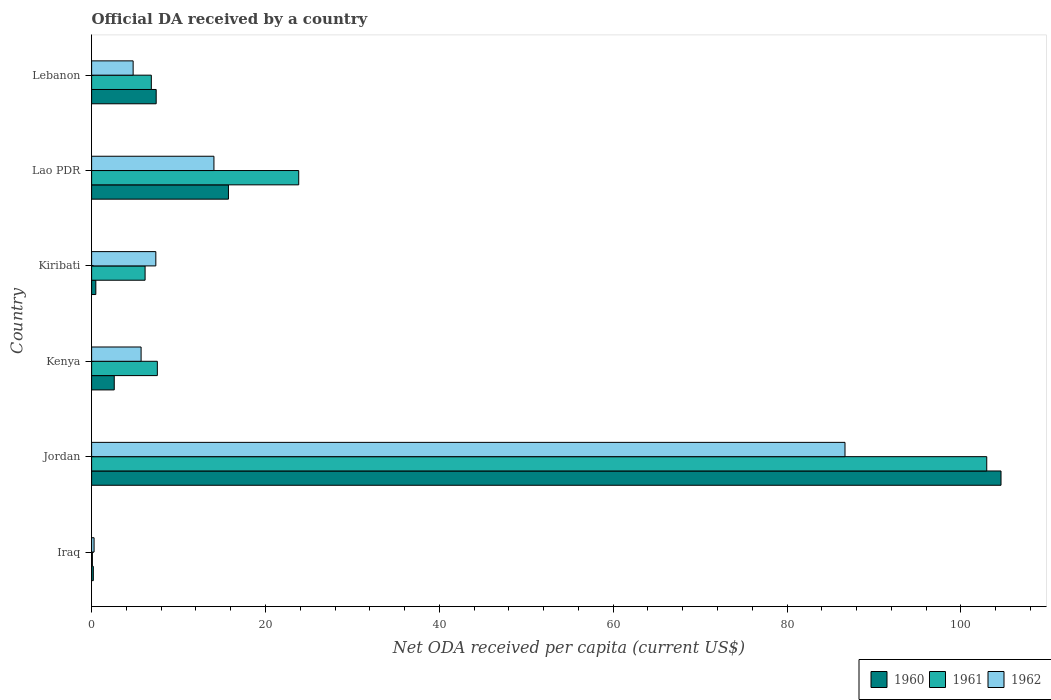How many different coloured bars are there?
Ensure brevity in your answer.  3. How many groups of bars are there?
Ensure brevity in your answer.  6. Are the number of bars per tick equal to the number of legend labels?
Make the answer very short. Yes. Are the number of bars on each tick of the Y-axis equal?
Give a very brief answer. Yes. What is the label of the 1st group of bars from the top?
Provide a succinct answer. Lebanon. In how many cases, is the number of bars for a given country not equal to the number of legend labels?
Keep it short and to the point. 0. What is the ODA received in in 1961 in Kenya?
Provide a succinct answer. 7.56. Across all countries, what is the maximum ODA received in in 1961?
Ensure brevity in your answer.  102.97. Across all countries, what is the minimum ODA received in in 1962?
Your answer should be compact. 0.28. In which country was the ODA received in in 1962 maximum?
Offer a terse response. Jordan. In which country was the ODA received in in 1962 minimum?
Give a very brief answer. Iraq. What is the total ODA received in in 1962 in the graph?
Your answer should be very brief. 118.88. What is the difference between the ODA received in in 1960 in Kenya and that in Kiribati?
Make the answer very short. 2.12. What is the difference between the ODA received in in 1961 in Kiribati and the ODA received in in 1962 in Lebanon?
Provide a short and direct response. 1.37. What is the average ODA received in in 1961 per country?
Give a very brief answer. 24.58. What is the difference between the ODA received in in 1960 and ODA received in in 1961 in Lebanon?
Your response must be concise. 0.56. In how many countries, is the ODA received in in 1962 greater than 104 US$?
Offer a terse response. 0. What is the ratio of the ODA received in in 1960 in Jordan to that in Lebanon?
Offer a very short reply. 14.08. Is the difference between the ODA received in in 1960 in Kenya and Lao PDR greater than the difference between the ODA received in in 1961 in Kenya and Lao PDR?
Your answer should be very brief. Yes. What is the difference between the highest and the second highest ODA received in in 1962?
Give a very brief answer. 72.59. What is the difference between the highest and the lowest ODA received in in 1962?
Your answer should be compact. 86.38. In how many countries, is the ODA received in in 1960 greater than the average ODA received in in 1960 taken over all countries?
Your response must be concise. 1. What does the 1st bar from the bottom in Kenya represents?
Offer a very short reply. 1960. Is it the case that in every country, the sum of the ODA received in in 1960 and ODA received in in 1962 is greater than the ODA received in in 1961?
Provide a succinct answer. Yes. How many countries are there in the graph?
Keep it short and to the point. 6. What is the difference between two consecutive major ticks on the X-axis?
Your response must be concise. 20. Where does the legend appear in the graph?
Provide a succinct answer. Bottom right. What is the title of the graph?
Your answer should be very brief. Official DA received by a country. What is the label or title of the X-axis?
Provide a succinct answer. Net ODA received per capita (current US$). What is the label or title of the Y-axis?
Keep it short and to the point. Country. What is the Net ODA received per capita (current US$) of 1960 in Iraq?
Give a very brief answer. 0.2. What is the Net ODA received per capita (current US$) of 1961 in Iraq?
Provide a short and direct response. 0.09. What is the Net ODA received per capita (current US$) in 1962 in Iraq?
Make the answer very short. 0.28. What is the Net ODA received per capita (current US$) in 1960 in Jordan?
Your response must be concise. 104.61. What is the Net ODA received per capita (current US$) in 1961 in Jordan?
Offer a very short reply. 102.97. What is the Net ODA received per capita (current US$) in 1962 in Jordan?
Offer a terse response. 86.66. What is the Net ODA received per capita (current US$) of 1960 in Kenya?
Make the answer very short. 2.6. What is the Net ODA received per capita (current US$) of 1961 in Kenya?
Make the answer very short. 7.56. What is the Net ODA received per capita (current US$) in 1962 in Kenya?
Give a very brief answer. 5.69. What is the Net ODA received per capita (current US$) of 1960 in Kiribati?
Make the answer very short. 0.49. What is the Net ODA received per capita (current US$) in 1961 in Kiribati?
Your response must be concise. 6.15. What is the Net ODA received per capita (current US$) of 1962 in Kiribati?
Your answer should be compact. 7.39. What is the Net ODA received per capita (current US$) of 1960 in Lao PDR?
Your answer should be compact. 15.74. What is the Net ODA received per capita (current US$) in 1961 in Lao PDR?
Make the answer very short. 23.82. What is the Net ODA received per capita (current US$) in 1962 in Lao PDR?
Your response must be concise. 14.07. What is the Net ODA received per capita (current US$) in 1960 in Lebanon?
Offer a terse response. 7.43. What is the Net ODA received per capita (current US$) of 1961 in Lebanon?
Keep it short and to the point. 6.87. What is the Net ODA received per capita (current US$) in 1962 in Lebanon?
Make the answer very short. 4.78. Across all countries, what is the maximum Net ODA received per capita (current US$) of 1960?
Make the answer very short. 104.61. Across all countries, what is the maximum Net ODA received per capita (current US$) of 1961?
Your answer should be compact. 102.97. Across all countries, what is the maximum Net ODA received per capita (current US$) in 1962?
Provide a succinct answer. 86.66. Across all countries, what is the minimum Net ODA received per capita (current US$) in 1960?
Provide a short and direct response. 0.2. Across all countries, what is the minimum Net ODA received per capita (current US$) in 1961?
Your answer should be compact. 0.09. Across all countries, what is the minimum Net ODA received per capita (current US$) of 1962?
Your response must be concise. 0.28. What is the total Net ODA received per capita (current US$) of 1960 in the graph?
Offer a terse response. 131.07. What is the total Net ODA received per capita (current US$) of 1961 in the graph?
Keep it short and to the point. 147.47. What is the total Net ODA received per capita (current US$) in 1962 in the graph?
Offer a very short reply. 118.88. What is the difference between the Net ODA received per capita (current US$) in 1960 in Iraq and that in Jordan?
Give a very brief answer. -104.41. What is the difference between the Net ODA received per capita (current US$) of 1961 in Iraq and that in Jordan?
Make the answer very short. -102.88. What is the difference between the Net ODA received per capita (current US$) of 1962 in Iraq and that in Jordan?
Your answer should be compact. -86.38. What is the difference between the Net ODA received per capita (current US$) of 1960 in Iraq and that in Kenya?
Provide a short and direct response. -2.41. What is the difference between the Net ODA received per capita (current US$) in 1961 in Iraq and that in Kenya?
Your answer should be very brief. -7.47. What is the difference between the Net ODA received per capita (current US$) in 1962 in Iraq and that in Kenya?
Your answer should be very brief. -5.41. What is the difference between the Net ODA received per capita (current US$) of 1960 in Iraq and that in Kiribati?
Your answer should be very brief. -0.29. What is the difference between the Net ODA received per capita (current US$) of 1961 in Iraq and that in Kiribati?
Provide a short and direct response. -6.06. What is the difference between the Net ODA received per capita (current US$) of 1962 in Iraq and that in Kiribati?
Keep it short and to the point. -7.1. What is the difference between the Net ODA received per capita (current US$) of 1960 in Iraq and that in Lao PDR?
Provide a succinct answer. -15.54. What is the difference between the Net ODA received per capita (current US$) in 1961 in Iraq and that in Lao PDR?
Keep it short and to the point. -23.73. What is the difference between the Net ODA received per capita (current US$) in 1962 in Iraq and that in Lao PDR?
Your response must be concise. -13.79. What is the difference between the Net ODA received per capita (current US$) of 1960 in Iraq and that in Lebanon?
Provide a succinct answer. -7.23. What is the difference between the Net ODA received per capita (current US$) in 1961 in Iraq and that in Lebanon?
Your answer should be very brief. -6.78. What is the difference between the Net ODA received per capita (current US$) in 1962 in Iraq and that in Lebanon?
Keep it short and to the point. -4.49. What is the difference between the Net ODA received per capita (current US$) in 1960 in Jordan and that in Kenya?
Your answer should be very brief. 102. What is the difference between the Net ODA received per capita (current US$) of 1961 in Jordan and that in Kenya?
Your response must be concise. 95.4. What is the difference between the Net ODA received per capita (current US$) in 1962 in Jordan and that in Kenya?
Offer a very short reply. 80.97. What is the difference between the Net ODA received per capita (current US$) of 1960 in Jordan and that in Kiribati?
Your response must be concise. 104.12. What is the difference between the Net ODA received per capita (current US$) of 1961 in Jordan and that in Kiribati?
Offer a very short reply. 96.81. What is the difference between the Net ODA received per capita (current US$) in 1962 in Jordan and that in Kiribati?
Provide a succinct answer. 79.27. What is the difference between the Net ODA received per capita (current US$) in 1960 in Jordan and that in Lao PDR?
Ensure brevity in your answer.  88.87. What is the difference between the Net ODA received per capita (current US$) of 1961 in Jordan and that in Lao PDR?
Make the answer very short. 79.14. What is the difference between the Net ODA received per capita (current US$) of 1962 in Jordan and that in Lao PDR?
Your response must be concise. 72.59. What is the difference between the Net ODA received per capita (current US$) in 1960 in Jordan and that in Lebanon?
Provide a succinct answer. 97.18. What is the difference between the Net ODA received per capita (current US$) in 1961 in Jordan and that in Lebanon?
Your answer should be compact. 96.1. What is the difference between the Net ODA received per capita (current US$) of 1962 in Jordan and that in Lebanon?
Your response must be concise. 81.88. What is the difference between the Net ODA received per capita (current US$) in 1960 in Kenya and that in Kiribati?
Give a very brief answer. 2.12. What is the difference between the Net ODA received per capita (current US$) in 1961 in Kenya and that in Kiribati?
Give a very brief answer. 1.41. What is the difference between the Net ODA received per capita (current US$) in 1962 in Kenya and that in Kiribati?
Offer a very short reply. -1.7. What is the difference between the Net ODA received per capita (current US$) of 1960 in Kenya and that in Lao PDR?
Give a very brief answer. -13.14. What is the difference between the Net ODA received per capita (current US$) in 1961 in Kenya and that in Lao PDR?
Your response must be concise. -16.26. What is the difference between the Net ODA received per capita (current US$) in 1962 in Kenya and that in Lao PDR?
Your answer should be very brief. -8.38. What is the difference between the Net ODA received per capita (current US$) of 1960 in Kenya and that in Lebanon?
Your answer should be compact. -4.83. What is the difference between the Net ODA received per capita (current US$) in 1961 in Kenya and that in Lebanon?
Your answer should be very brief. 0.69. What is the difference between the Net ODA received per capita (current US$) of 1962 in Kenya and that in Lebanon?
Your answer should be compact. 0.91. What is the difference between the Net ODA received per capita (current US$) in 1960 in Kiribati and that in Lao PDR?
Your response must be concise. -15.26. What is the difference between the Net ODA received per capita (current US$) in 1961 in Kiribati and that in Lao PDR?
Provide a short and direct response. -17.67. What is the difference between the Net ODA received per capita (current US$) of 1962 in Kiribati and that in Lao PDR?
Keep it short and to the point. -6.68. What is the difference between the Net ODA received per capita (current US$) of 1960 in Kiribati and that in Lebanon?
Give a very brief answer. -6.94. What is the difference between the Net ODA received per capita (current US$) of 1961 in Kiribati and that in Lebanon?
Make the answer very short. -0.72. What is the difference between the Net ODA received per capita (current US$) of 1962 in Kiribati and that in Lebanon?
Ensure brevity in your answer.  2.61. What is the difference between the Net ODA received per capita (current US$) of 1960 in Lao PDR and that in Lebanon?
Make the answer very short. 8.31. What is the difference between the Net ODA received per capita (current US$) of 1961 in Lao PDR and that in Lebanon?
Provide a short and direct response. 16.95. What is the difference between the Net ODA received per capita (current US$) of 1962 in Lao PDR and that in Lebanon?
Offer a terse response. 9.29. What is the difference between the Net ODA received per capita (current US$) of 1960 in Iraq and the Net ODA received per capita (current US$) of 1961 in Jordan?
Offer a very short reply. -102.77. What is the difference between the Net ODA received per capita (current US$) in 1960 in Iraq and the Net ODA received per capita (current US$) in 1962 in Jordan?
Make the answer very short. -86.46. What is the difference between the Net ODA received per capita (current US$) of 1961 in Iraq and the Net ODA received per capita (current US$) of 1962 in Jordan?
Ensure brevity in your answer.  -86.57. What is the difference between the Net ODA received per capita (current US$) in 1960 in Iraq and the Net ODA received per capita (current US$) in 1961 in Kenya?
Ensure brevity in your answer.  -7.36. What is the difference between the Net ODA received per capita (current US$) of 1960 in Iraq and the Net ODA received per capita (current US$) of 1962 in Kenya?
Your response must be concise. -5.49. What is the difference between the Net ODA received per capita (current US$) of 1961 in Iraq and the Net ODA received per capita (current US$) of 1962 in Kenya?
Ensure brevity in your answer.  -5.6. What is the difference between the Net ODA received per capita (current US$) in 1960 in Iraq and the Net ODA received per capita (current US$) in 1961 in Kiribati?
Provide a short and direct response. -5.95. What is the difference between the Net ODA received per capita (current US$) in 1960 in Iraq and the Net ODA received per capita (current US$) in 1962 in Kiribati?
Provide a short and direct response. -7.19. What is the difference between the Net ODA received per capita (current US$) of 1961 in Iraq and the Net ODA received per capita (current US$) of 1962 in Kiribati?
Offer a terse response. -7.3. What is the difference between the Net ODA received per capita (current US$) of 1960 in Iraq and the Net ODA received per capita (current US$) of 1961 in Lao PDR?
Provide a succinct answer. -23.62. What is the difference between the Net ODA received per capita (current US$) of 1960 in Iraq and the Net ODA received per capita (current US$) of 1962 in Lao PDR?
Make the answer very short. -13.87. What is the difference between the Net ODA received per capita (current US$) in 1961 in Iraq and the Net ODA received per capita (current US$) in 1962 in Lao PDR?
Provide a short and direct response. -13.98. What is the difference between the Net ODA received per capita (current US$) of 1960 in Iraq and the Net ODA received per capita (current US$) of 1961 in Lebanon?
Provide a succinct answer. -6.67. What is the difference between the Net ODA received per capita (current US$) of 1960 in Iraq and the Net ODA received per capita (current US$) of 1962 in Lebanon?
Provide a succinct answer. -4.58. What is the difference between the Net ODA received per capita (current US$) of 1961 in Iraq and the Net ODA received per capita (current US$) of 1962 in Lebanon?
Provide a short and direct response. -4.69. What is the difference between the Net ODA received per capita (current US$) in 1960 in Jordan and the Net ODA received per capita (current US$) in 1961 in Kenya?
Provide a short and direct response. 97.05. What is the difference between the Net ODA received per capita (current US$) in 1960 in Jordan and the Net ODA received per capita (current US$) in 1962 in Kenya?
Keep it short and to the point. 98.92. What is the difference between the Net ODA received per capita (current US$) of 1961 in Jordan and the Net ODA received per capita (current US$) of 1962 in Kenya?
Provide a succinct answer. 97.27. What is the difference between the Net ODA received per capita (current US$) of 1960 in Jordan and the Net ODA received per capita (current US$) of 1961 in Kiribati?
Your response must be concise. 98.46. What is the difference between the Net ODA received per capita (current US$) of 1960 in Jordan and the Net ODA received per capita (current US$) of 1962 in Kiribati?
Offer a very short reply. 97.22. What is the difference between the Net ODA received per capita (current US$) of 1961 in Jordan and the Net ODA received per capita (current US$) of 1962 in Kiribati?
Your answer should be very brief. 95.58. What is the difference between the Net ODA received per capita (current US$) in 1960 in Jordan and the Net ODA received per capita (current US$) in 1961 in Lao PDR?
Provide a short and direct response. 80.79. What is the difference between the Net ODA received per capita (current US$) of 1960 in Jordan and the Net ODA received per capita (current US$) of 1962 in Lao PDR?
Offer a very short reply. 90.54. What is the difference between the Net ODA received per capita (current US$) in 1961 in Jordan and the Net ODA received per capita (current US$) in 1962 in Lao PDR?
Your answer should be very brief. 88.89. What is the difference between the Net ODA received per capita (current US$) in 1960 in Jordan and the Net ODA received per capita (current US$) in 1961 in Lebanon?
Offer a terse response. 97.74. What is the difference between the Net ODA received per capita (current US$) in 1960 in Jordan and the Net ODA received per capita (current US$) in 1962 in Lebanon?
Provide a succinct answer. 99.83. What is the difference between the Net ODA received per capita (current US$) of 1961 in Jordan and the Net ODA received per capita (current US$) of 1962 in Lebanon?
Your answer should be compact. 98.19. What is the difference between the Net ODA received per capita (current US$) of 1960 in Kenya and the Net ODA received per capita (current US$) of 1961 in Kiribati?
Offer a terse response. -3.55. What is the difference between the Net ODA received per capita (current US$) in 1960 in Kenya and the Net ODA received per capita (current US$) in 1962 in Kiribati?
Provide a short and direct response. -4.78. What is the difference between the Net ODA received per capita (current US$) in 1961 in Kenya and the Net ODA received per capita (current US$) in 1962 in Kiribati?
Your answer should be compact. 0.17. What is the difference between the Net ODA received per capita (current US$) of 1960 in Kenya and the Net ODA received per capita (current US$) of 1961 in Lao PDR?
Offer a very short reply. -21.22. What is the difference between the Net ODA received per capita (current US$) of 1960 in Kenya and the Net ODA received per capita (current US$) of 1962 in Lao PDR?
Your answer should be very brief. -11.47. What is the difference between the Net ODA received per capita (current US$) of 1961 in Kenya and the Net ODA received per capita (current US$) of 1962 in Lao PDR?
Your answer should be compact. -6.51. What is the difference between the Net ODA received per capita (current US$) in 1960 in Kenya and the Net ODA received per capita (current US$) in 1961 in Lebanon?
Your response must be concise. -4.27. What is the difference between the Net ODA received per capita (current US$) in 1960 in Kenya and the Net ODA received per capita (current US$) in 1962 in Lebanon?
Your answer should be very brief. -2.17. What is the difference between the Net ODA received per capita (current US$) in 1961 in Kenya and the Net ODA received per capita (current US$) in 1962 in Lebanon?
Keep it short and to the point. 2.78. What is the difference between the Net ODA received per capita (current US$) in 1960 in Kiribati and the Net ODA received per capita (current US$) in 1961 in Lao PDR?
Offer a very short reply. -23.34. What is the difference between the Net ODA received per capita (current US$) in 1960 in Kiribati and the Net ODA received per capita (current US$) in 1962 in Lao PDR?
Your answer should be compact. -13.59. What is the difference between the Net ODA received per capita (current US$) in 1961 in Kiribati and the Net ODA received per capita (current US$) in 1962 in Lao PDR?
Offer a terse response. -7.92. What is the difference between the Net ODA received per capita (current US$) of 1960 in Kiribati and the Net ODA received per capita (current US$) of 1961 in Lebanon?
Your response must be concise. -6.39. What is the difference between the Net ODA received per capita (current US$) in 1960 in Kiribati and the Net ODA received per capita (current US$) in 1962 in Lebanon?
Offer a very short reply. -4.29. What is the difference between the Net ODA received per capita (current US$) in 1961 in Kiribati and the Net ODA received per capita (current US$) in 1962 in Lebanon?
Offer a very short reply. 1.37. What is the difference between the Net ODA received per capita (current US$) in 1960 in Lao PDR and the Net ODA received per capita (current US$) in 1961 in Lebanon?
Your answer should be compact. 8.87. What is the difference between the Net ODA received per capita (current US$) of 1960 in Lao PDR and the Net ODA received per capita (current US$) of 1962 in Lebanon?
Your answer should be very brief. 10.96. What is the difference between the Net ODA received per capita (current US$) in 1961 in Lao PDR and the Net ODA received per capita (current US$) in 1962 in Lebanon?
Ensure brevity in your answer.  19.05. What is the average Net ODA received per capita (current US$) of 1960 per country?
Make the answer very short. 21.84. What is the average Net ODA received per capita (current US$) of 1961 per country?
Your response must be concise. 24.58. What is the average Net ODA received per capita (current US$) of 1962 per country?
Keep it short and to the point. 19.81. What is the difference between the Net ODA received per capita (current US$) in 1960 and Net ODA received per capita (current US$) in 1961 in Iraq?
Offer a terse response. 0.11. What is the difference between the Net ODA received per capita (current US$) of 1960 and Net ODA received per capita (current US$) of 1962 in Iraq?
Ensure brevity in your answer.  -0.09. What is the difference between the Net ODA received per capita (current US$) in 1961 and Net ODA received per capita (current US$) in 1962 in Iraq?
Your answer should be very brief. -0.19. What is the difference between the Net ODA received per capita (current US$) in 1960 and Net ODA received per capita (current US$) in 1961 in Jordan?
Provide a succinct answer. 1.64. What is the difference between the Net ODA received per capita (current US$) in 1960 and Net ODA received per capita (current US$) in 1962 in Jordan?
Provide a succinct answer. 17.95. What is the difference between the Net ODA received per capita (current US$) of 1961 and Net ODA received per capita (current US$) of 1962 in Jordan?
Make the answer very short. 16.3. What is the difference between the Net ODA received per capita (current US$) of 1960 and Net ODA received per capita (current US$) of 1961 in Kenya?
Your answer should be compact. -4.96. What is the difference between the Net ODA received per capita (current US$) in 1960 and Net ODA received per capita (current US$) in 1962 in Kenya?
Provide a short and direct response. -3.09. What is the difference between the Net ODA received per capita (current US$) of 1961 and Net ODA received per capita (current US$) of 1962 in Kenya?
Ensure brevity in your answer.  1.87. What is the difference between the Net ODA received per capita (current US$) of 1960 and Net ODA received per capita (current US$) of 1961 in Kiribati?
Your response must be concise. -5.67. What is the difference between the Net ODA received per capita (current US$) of 1960 and Net ODA received per capita (current US$) of 1962 in Kiribati?
Your response must be concise. -6.9. What is the difference between the Net ODA received per capita (current US$) of 1961 and Net ODA received per capita (current US$) of 1962 in Kiribati?
Your answer should be compact. -1.24. What is the difference between the Net ODA received per capita (current US$) of 1960 and Net ODA received per capita (current US$) of 1961 in Lao PDR?
Make the answer very short. -8.08. What is the difference between the Net ODA received per capita (current US$) of 1960 and Net ODA received per capita (current US$) of 1962 in Lao PDR?
Ensure brevity in your answer.  1.67. What is the difference between the Net ODA received per capita (current US$) of 1961 and Net ODA received per capita (current US$) of 1962 in Lao PDR?
Give a very brief answer. 9.75. What is the difference between the Net ODA received per capita (current US$) of 1960 and Net ODA received per capita (current US$) of 1961 in Lebanon?
Offer a terse response. 0.56. What is the difference between the Net ODA received per capita (current US$) in 1960 and Net ODA received per capita (current US$) in 1962 in Lebanon?
Offer a terse response. 2.65. What is the difference between the Net ODA received per capita (current US$) of 1961 and Net ODA received per capita (current US$) of 1962 in Lebanon?
Keep it short and to the point. 2.09. What is the ratio of the Net ODA received per capita (current US$) of 1960 in Iraq to that in Jordan?
Your response must be concise. 0. What is the ratio of the Net ODA received per capita (current US$) of 1961 in Iraq to that in Jordan?
Offer a very short reply. 0. What is the ratio of the Net ODA received per capita (current US$) in 1962 in Iraq to that in Jordan?
Your answer should be very brief. 0. What is the ratio of the Net ODA received per capita (current US$) of 1960 in Iraq to that in Kenya?
Offer a terse response. 0.08. What is the ratio of the Net ODA received per capita (current US$) of 1961 in Iraq to that in Kenya?
Provide a short and direct response. 0.01. What is the ratio of the Net ODA received per capita (current US$) in 1962 in Iraq to that in Kenya?
Ensure brevity in your answer.  0.05. What is the ratio of the Net ODA received per capita (current US$) of 1960 in Iraq to that in Kiribati?
Your answer should be compact. 0.41. What is the ratio of the Net ODA received per capita (current US$) in 1961 in Iraq to that in Kiribati?
Give a very brief answer. 0.01. What is the ratio of the Net ODA received per capita (current US$) in 1962 in Iraq to that in Kiribati?
Keep it short and to the point. 0.04. What is the ratio of the Net ODA received per capita (current US$) in 1960 in Iraq to that in Lao PDR?
Ensure brevity in your answer.  0.01. What is the ratio of the Net ODA received per capita (current US$) of 1961 in Iraq to that in Lao PDR?
Ensure brevity in your answer.  0. What is the ratio of the Net ODA received per capita (current US$) of 1962 in Iraq to that in Lao PDR?
Make the answer very short. 0.02. What is the ratio of the Net ODA received per capita (current US$) in 1960 in Iraq to that in Lebanon?
Ensure brevity in your answer.  0.03. What is the ratio of the Net ODA received per capita (current US$) in 1961 in Iraq to that in Lebanon?
Your answer should be very brief. 0.01. What is the ratio of the Net ODA received per capita (current US$) of 1962 in Iraq to that in Lebanon?
Make the answer very short. 0.06. What is the ratio of the Net ODA received per capita (current US$) in 1960 in Jordan to that in Kenya?
Ensure brevity in your answer.  40.17. What is the ratio of the Net ODA received per capita (current US$) of 1961 in Jordan to that in Kenya?
Keep it short and to the point. 13.62. What is the ratio of the Net ODA received per capita (current US$) of 1962 in Jordan to that in Kenya?
Your answer should be compact. 15.22. What is the ratio of the Net ODA received per capita (current US$) of 1960 in Jordan to that in Kiribati?
Keep it short and to the point. 215.67. What is the ratio of the Net ODA received per capita (current US$) in 1961 in Jordan to that in Kiribati?
Your answer should be very brief. 16.74. What is the ratio of the Net ODA received per capita (current US$) of 1962 in Jordan to that in Kiribati?
Provide a short and direct response. 11.73. What is the ratio of the Net ODA received per capita (current US$) of 1960 in Jordan to that in Lao PDR?
Your response must be concise. 6.65. What is the ratio of the Net ODA received per capita (current US$) in 1961 in Jordan to that in Lao PDR?
Provide a succinct answer. 4.32. What is the ratio of the Net ODA received per capita (current US$) of 1962 in Jordan to that in Lao PDR?
Give a very brief answer. 6.16. What is the ratio of the Net ODA received per capita (current US$) in 1960 in Jordan to that in Lebanon?
Your response must be concise. 14.08. What is the ratio of the Net ODA received per capita (current US$) in 1961 in Jordan to that in Lebanon?
Offer a terse response. 14.99. What is the ratio of the Net ODA received per capita (current US$) in 1962 in Jordan to that in Lebanon?
Provide a short and direct response. 18.14. What is the ratio of the Net ODA received per capita (current US$) in 1960 in Kenya to that in Kiribati?
Ensure brevity in your answer.  5.37. What is the ratio of the Net ODA received per capita (current US$) in 1961 in Kenya to that in Kiribati?
Give a very brief answer. 1.23. What is the ratio of the Net ODA received per capita (current US$) of 1962 in Kenya to that in Kiribati?
Provide a short and direct response. 0.77. What is the ratio of the Net ODA received per capita (current US$) in 1960 in Kenya to that in Lao PDR?
Ensure brevity in your answer.  0.17. What is the ratio of the Net ODA received per capita (current US$) of 1961 in Kenya to that in Lao PDR?
Your answer should be very brief. 0.32. What is the ratio of the Net ODA received per capita (current US$) of 1962 in Kenya to that in Lao PDR?
Offer a very short reply. 0.4. What is the ratio of the Net ODA received per capita (current US$) of 1960 in Kenya to that in Lebanon?
Offer a terse response. 0.35. What is the ratio of the Net ODA received per capita (current US$) of 1961 in Kenya to that in Lebanon?
Offer a terse response. 1.1. What is the ratio of the Net ODA received per capita (current US$) in 1962 in Kenya to that in Lebanon?
Offer a very short reply. 1.19. What is the ratio of the Net ODA received per capita (current US$) in 1960 in Kiribati to that in Lao PDR?
Your answer should be compact. 0.03. What is the ratio of the Net ODA received per capita (current US$) of 1961 in Kiribati to that in Lao PDR?
Give a very brief answer. 0.26. What is the ratio of the Net ODA received per capita (current US$) of 1962 in Kiribati to that in Lao PDR?
Provide a short and direct response. 0.53. What is the ratio of the Net ODA received per capita (current US$) in 1960 in Kiribati to that in Lebanon?
Provide a short and direct response. 0.07. What is the ratio of the Net ODA received per capita (current US$) of 1961 in Kiribati to that in Lebanon?
Keep it short and to the point. 0.9. What is the ratio of the Net ODA received per capita (current US$) in 1962 in Kiribati to that in Lebanon?
Provide a succinct answer. 1.55. What is the ratio of the Net ODA received per capita (current US$) of 1960 in Lao PDR to that in Lebanon?
Your answer should be compact. 2.12. What is the ratio of the Net ODA received per capita (current US$) of 1961 in Lao PDR to that in Lebanon?
Your response must be concise. 3.47. What is the ratio of the Net ODA received per capita (current US$) of 1962 in Lao PDR to that in Lebanon?
Your answer should be compact. 2.94. What is the difference between the highest and the second highest Net ODA received per capita (current US$) of 1960?
Your answer should be compact. 88.87. What is the difference between the highest and the second highest Net ODA received per capita (current US$) in 1961?
Ensure brevity in your answer.  79.14. What is the difference between the highest and the second highest Net ODA received per capita (current US$) of 1962?
Ensure brevity in your answer.  72.59. What is the difference between the highest and the lowest Net ODA received per capita (current US$) in 1960?
Your response must be concise. 104.41. What is the difference between the highest and the lowest Net ODA received per capita (current US$) of 1961?
Your answer should be very brief. 102.88. What is the difference between the highest and the lowest Net ODA received per capita (current US$) of 1962?
Provide a short and direct response. 86.38. 